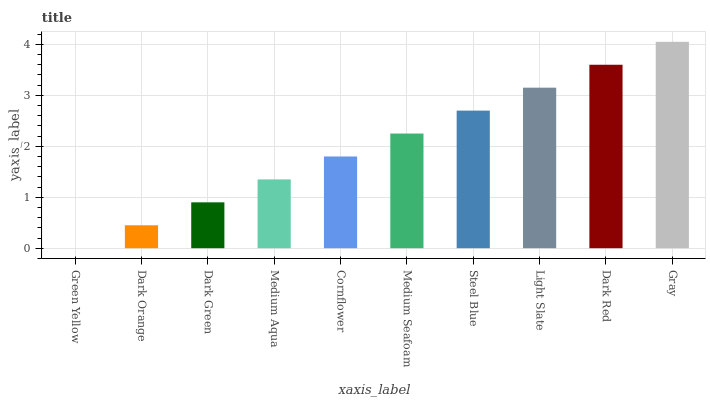Is Green Yellow the minimum?
Answer yes or no. Yes. Is Gray the maximum?
Answer yes or no. Yes. Is Dark Orange the minimum?
Answer yes or no. No. Is Dark Orange the maximum?
Answer yes or no. No. Is Dark Orange greater than Green Yellow?
Answer yes or no. Yes. Is Green Yellow less than Dark Orange?
Answer yes or no. Yes. Is Green Yellow greater than Dark Orange?
Answer yes or no. No. Is Dark Orange less than Green Yellow?
Answer yes or no. No. Is Medium Seafoam the high median?
Answer yes or no. Yes. Is Cornflower the low median?
Answer yes or no. Yes. Is Steel Blue the high median?
Answer yes or no. No. Is Light Slate the low median?
Answer yes or no. No. 